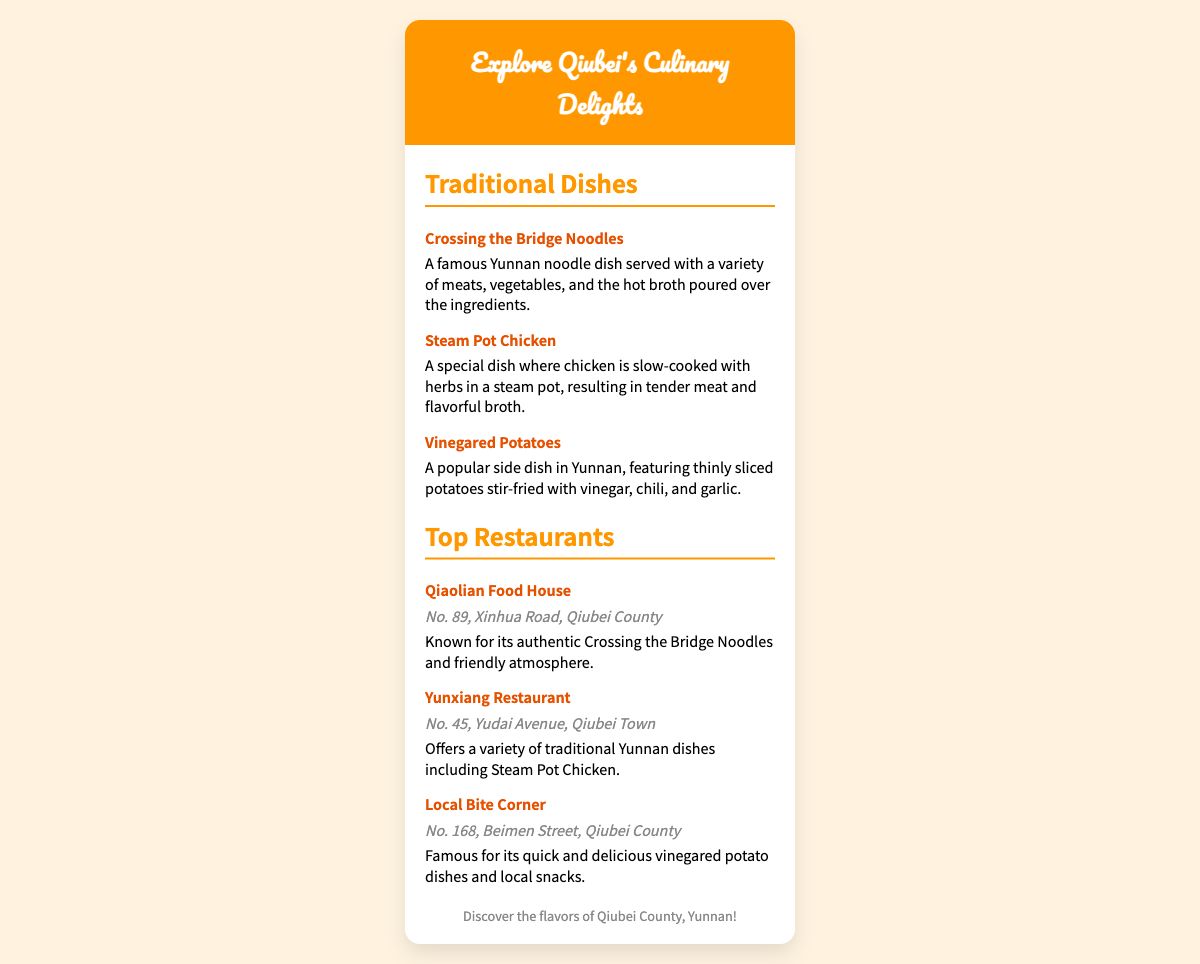what is the name of the popular Yunnan noodle dish mentioned? The document lists "Crossing the Bridge Noodles" as a famous Yunnan noodle dish.
Answer: Crossing the Bridge Noodles what is one of the key ingredients in Steam Pot Chicken? The description specifies that the chicken is cooked with herbs, which are key ingredients in this dish.
Answer: Herbs what is the address of Qiaolian Food House? The document provides the address of Qiaolian Food House, which is found within the text.
Answer: No. 89, Xinhua Road, Qiubei County how many traditional dishes are listed in the document? The document specifically lists three traditional dishes under the "Traditional Dishes" section.
Answer: Three which restaurant is famous for vinegared potato dishes? The document explicitly states that Local Bite Corner is known for its vinegared potato dishes.
Answer: Local Bite Corner what is a notable feature of the atmosphere at Qiaolian Food House? The document describes the atmosphere as "friendly," highlighting its appeal to visitors.
Answer: Friendly atmosphere what type of cuisine can you find at Yunxiang Restaurant? The document mentions that Yunxiang Restaurant offers a variety of traditional Yunnan dishes.
Answer: Traditional Yunnan dishes which dish is specifically noted for being stir-fried with vinegar? The document describes "Vinegared Potatoes" as being stir-fried with vinegar.
Answer: Vinegared Potatoes what is the main selling point of Local Bite Corner? The main selling point highlighted is its quick and delicious vinegared potato dishes.
Answer: Quick and delicious vinegared potato dishes 